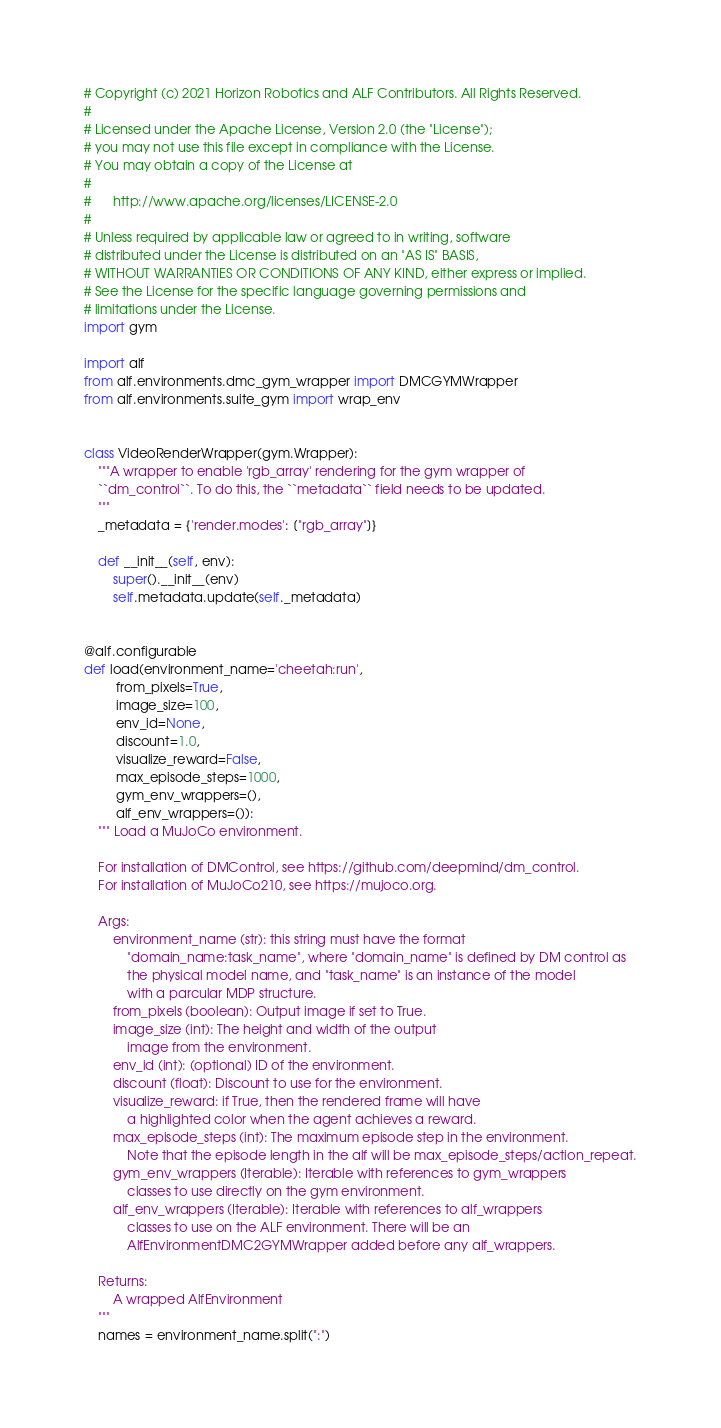Convert code to text. <code><loc_0><loc_0><loc_500><loc_500><_Python_># Copyright (c) 2021 Horizon Robotics and ALF Contributors. All Rights Reserved.
#
# Licensed under the Apache License, Version 2.0 (the "License");
# you may not use this file except in compliance with the License.
# You may obtain a copy of the License at
#
#      http://www.apache.org/licenses/LICENSE-2.0
#
# Unless required by applicable law or agreed to in writing, software
# distributed under the License is distributed on an "AS IS" BASIS,
# WITHOUT WARRANTIES OR CONDITIONS OF ANY KIND, either express or implied.
# See the License for the specific language governing permissions and
# limitations under the License.
import gym

import alf
from alf.environments.dmc_gym_wrapper import DMCGYMWrapper
from alf.environments.suite_gym import wrap_env


class VideoRenderWrapper(gym.Wrapper):
    """A wrapper to enable 'rgb_array' rendering for the gym wrapper of
    ``dm_control``. To do this, the ``metadata`` field needs to be updated.
    """
    _metadata = {'render.modes': ["rgb_array"]}

    def __init__(self, env):
        super().__init__(env)
        self.metadata.update(self._metadata)


@alf.configurable
def load(environment_name='cheetah:run',
         from_pixels=True,
         image_size=100,
         env_id=None,
         discount=1.0,
         visualize_reward=False,
         max_episode_steps=1000,
         gym_env_wrappers=(),
         alf_env_wrappers=()):
    """ Load a MuJoCo environment.

    For installation of DMControl, see https://github.com/deepmind/dm_control.
    For installation of MuJoCo210, see https://mujoco.org.

    Args:
        environment_name (str): this string must have the format
            "domain_name:task_name", where "domain_name" is defined by DM control as
            the physical model name, and "task_name" is an instance of the model
            with a parcular MDP structure.
        from_pixels (boolean): Output image if set to True.
        image_size (int): The height and width of the output
            image from the environment.
        env_id (int): (optional) ID of the environment.
        discount (float): Discount to use for the environment.
        visualize_reward: if True, then the rendered frame will have
            a highlighted color when the agent achieves a reward.
        max_episode_steps (int): The maximum episode step in the environment.
            Note that the episode length in the alf will be max_episode_steps/action_repeat.
        gym_env_wrappers (Iterable): Iterable with references to gym_wrappers
            classes to use directly on the gym environment.
        alf_env_wrappers (Iterable): Iterable with references to alf_wrappers
            classes to use on the ALF environment. There will be an
            AlfEnvironmentDMC2GYMWrapper added before any alf_wrappers.

    Returns:
        A wrapped AlfEnvironment
    """
    names = environment_name.split(":")</code> 